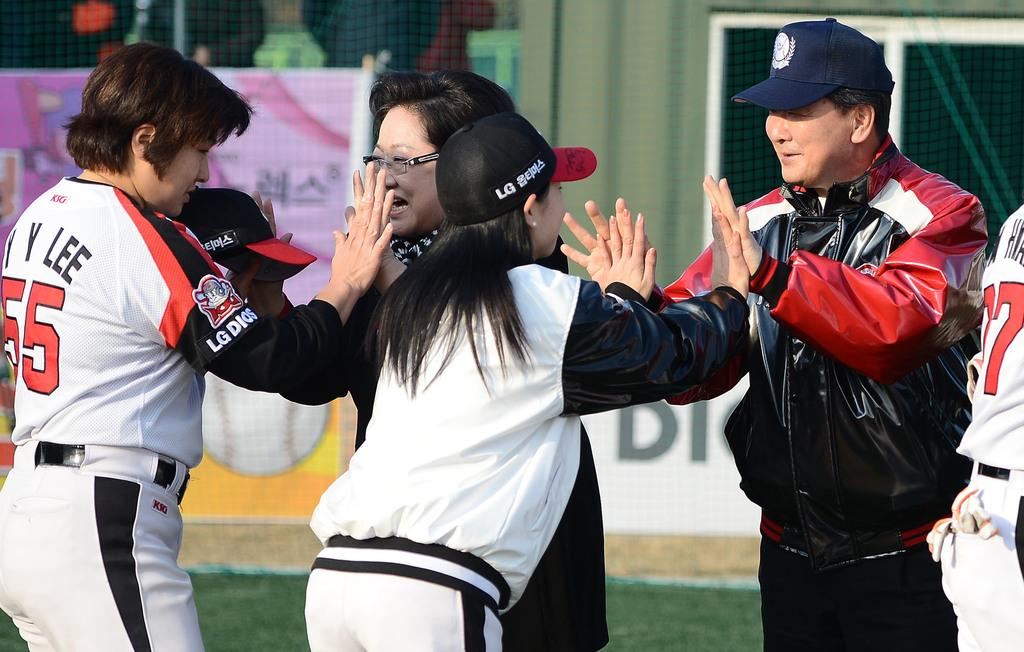<image>
Summarize the visual content of the image. Player number 55 gives a high five to a woman in glasses. 